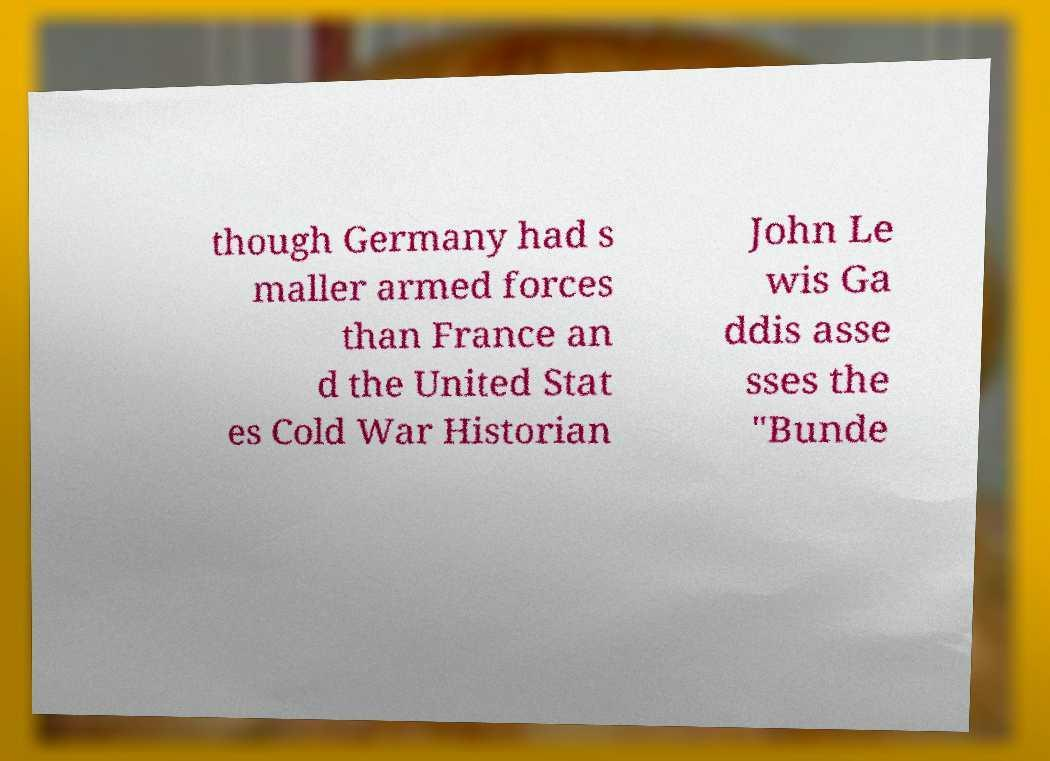Can you accurately transcribe the text from the provided image for me? though Germany had s maller armed forces than France an d the United Stat es Cold War Historian John Le wis Ga ddis asse sses the "Bunde 